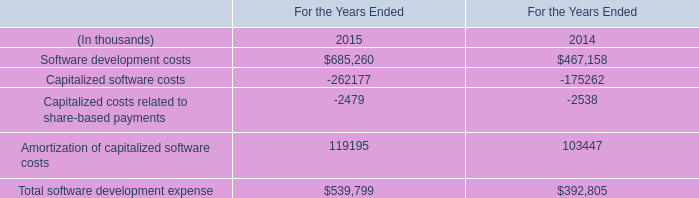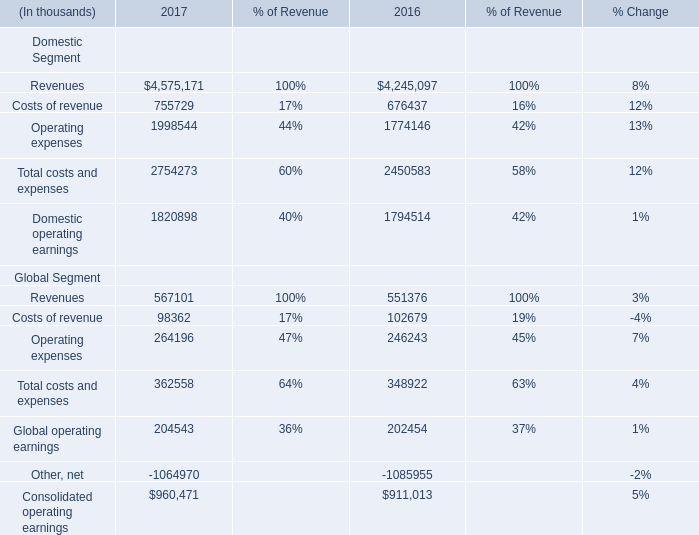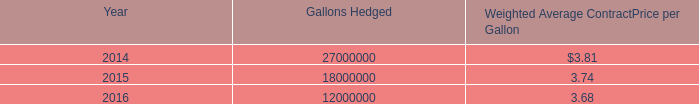what was the growth percent of the total gain ( loss ) recognized in other comprehensive income for fuel hedges from 2012 to 2013 
Computations: ((2.4 - 3.4) / 3.4)
Answer: -0.29412. 